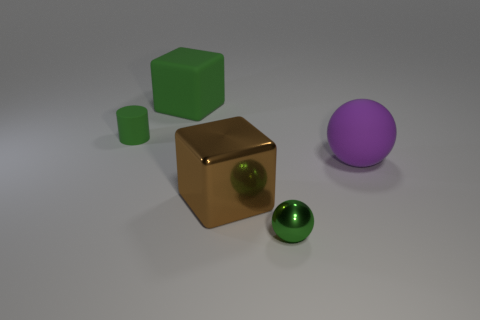Add 3 small red spheres. How many objects exist? 8 Subtract all cylinders. How many objects are left? 4 Subtract 1 green balls. How many objects are left? 4 Subtract all big green blocks. Subtract all big rubber spheres. How many objects are left? 3 Add 1 big purple rubber objects. How many big purple rubber objects are left? 2 Add 3 gray objects. How many gray objects exist? 3 